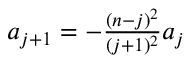Convert formula to latex. <formula><loc_0><loc_0><loc_500><loc_500>\begin{array} { r } { a _ { j + 1 } = - \frac { ( n - j ) ^ { 2 } } { ( j + 1 ) ^ { 2 } } a _ { j } } \end{array}</formula> 